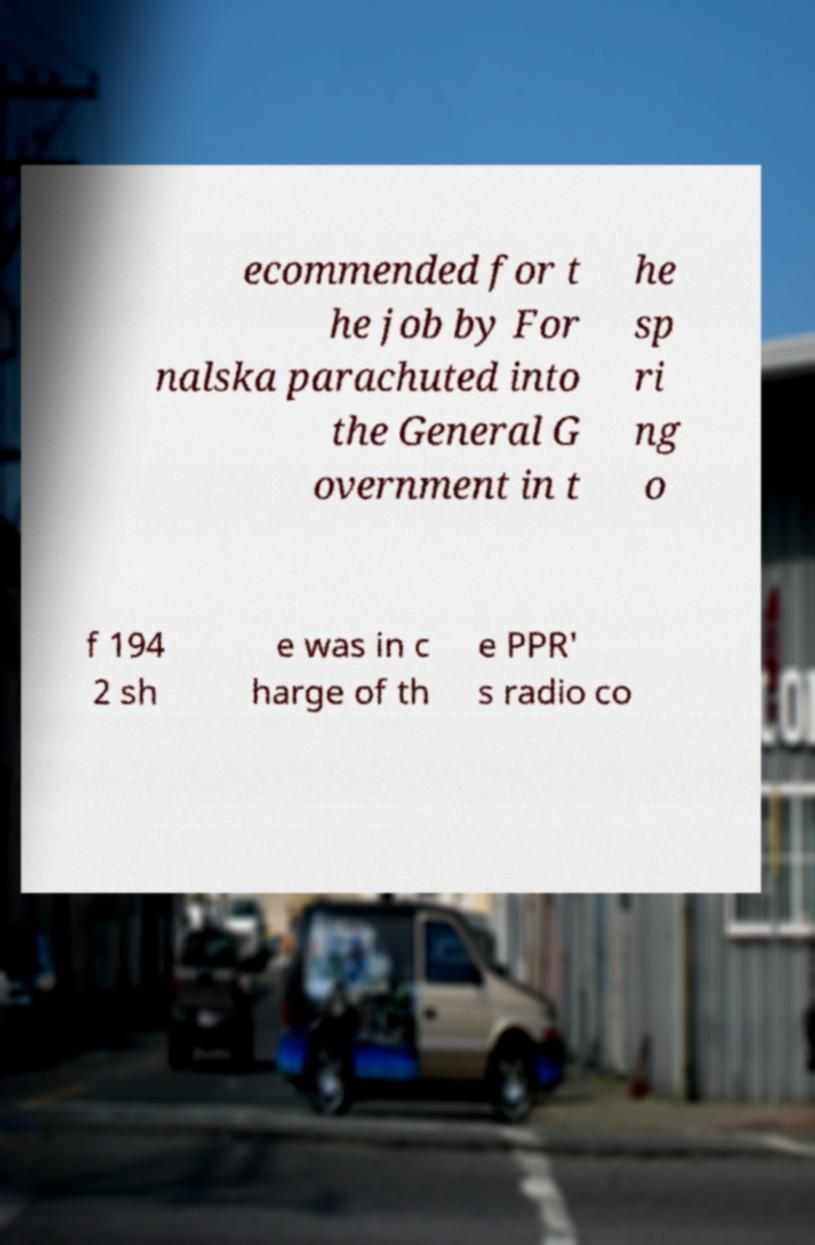What messages or text are displayed in this image? I need them in a readable, typed format. ecommended for t he job by For nalska parachuted into the General G overnment in t he sp ri ng o f 194 2 sh e was in c harge of th e PPR' s radio co 